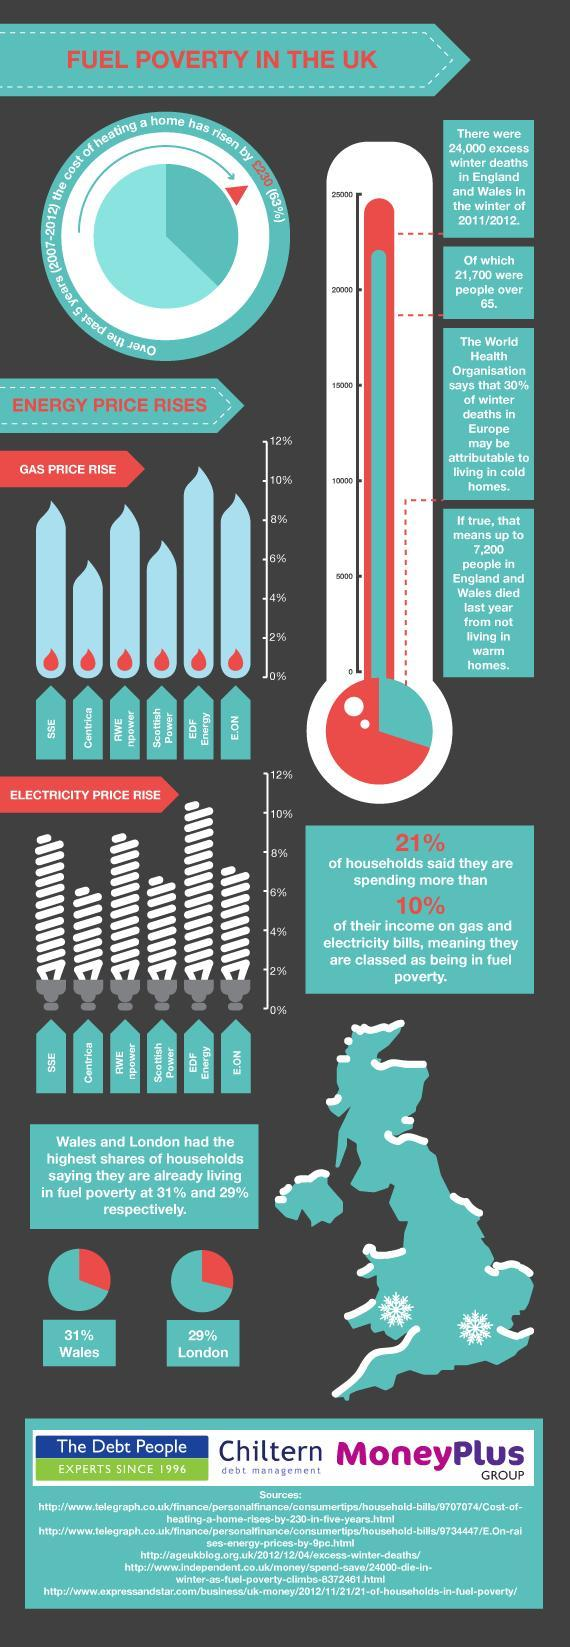Which company has the lowest percentage of electricity price rise?
Answer the question with a short phrase. Centrica How many electric bulbs are in this infographic? 6 Which company has the highest percentage of electricity price rise? EDF Energy Which company has the lowest percentage of gas price rise? Centrica What is the percentage increase in gas price in Scottish power? 7% How many peoples died are below 65? 2300 